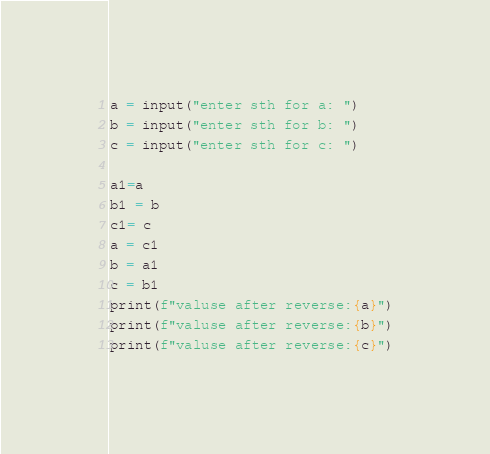<code> <loc_0><loc_0><loc_500><loc_500><_Python_>a = input("enter sth for a: ")
b = input("enter sth for b: ")
c = input("enter sth for c: ")

a1=a
b1 = b
c1= c
a = c1
b = a1
c = b1
print(f"valuse after reverse:{a}")
print(f"valuse after reverse:{b}")
print(f"valuse after reverse:{c}")</code> 